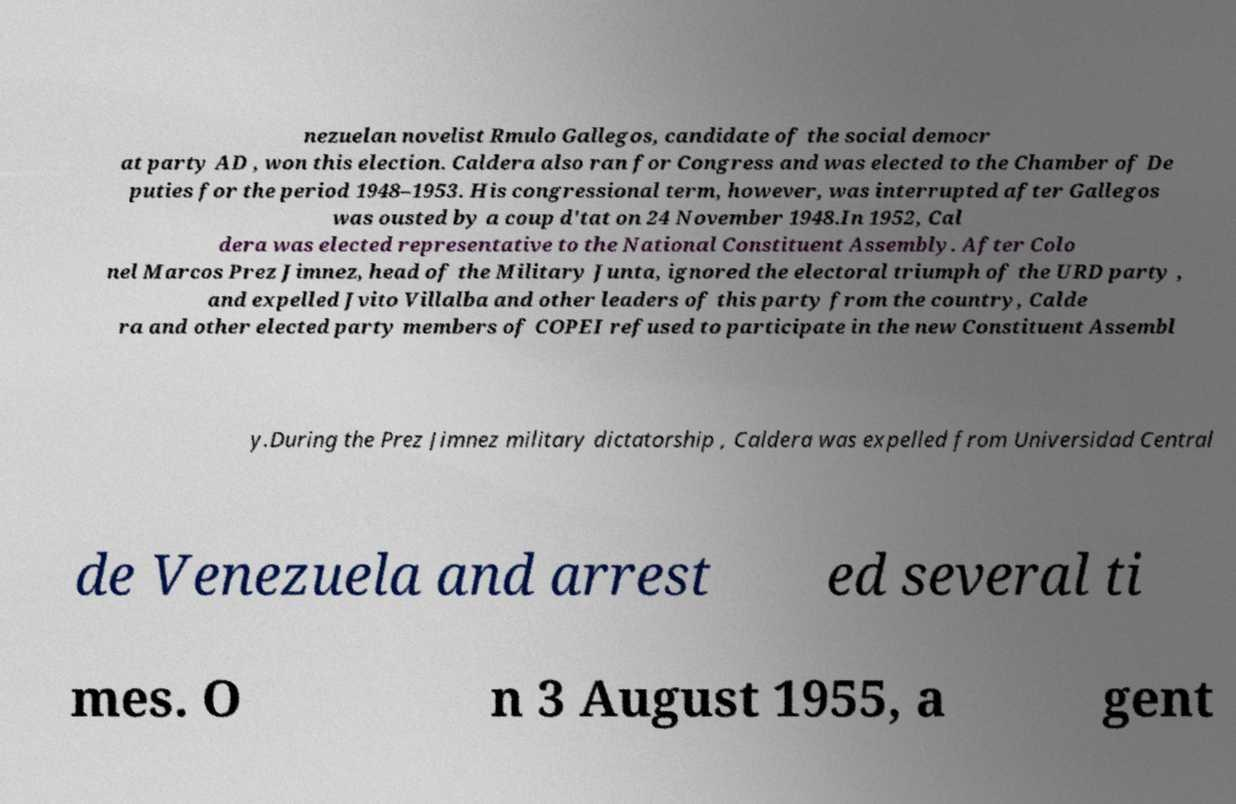There's text embedded in this image that I need extracted. Can you transcribe it verbatim? nezuelan novelist Rmulo Gallegos, candidate of the social democr at party AD , won this election. Caldera also ran for Congress and was elected to the Chamber of De puties for the period 1948–1953. His congressional term, however, was interrupted after Gallegos was ousted by a coup d'tat on 24 November 1948.In 1952, Cal dera was elected representative to the National Constituent Assembly. After Colo nel Marcos Prez Jimnez, head of the Military Junta, ignored the electoral triumph of the URD party , and expelled Jvito Villalba and other leaders of this party from the country, Calde ra and other elected party members of COPEI refused to participate in the new Constituent Assembl y.During the Prez Jimnez military dictatorship , Caldera was expelled from Universidad Central de Venezuela and arrest ed several ti mes. O n 3 August 1955, a gent 